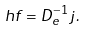<formula> <loc_0><loc_0><loc_500><loc_500>\ h f = D _ { e } ^ { - 1 } j .</formula> 